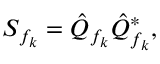<formula> <loc_0><loc_0><loc_500><loc_500>S _ { f _ { k } } = \hat { Q } _ { f _ { k } } \hat { Q } _ { f _ { k } } ^ { \ast } ,</formula> 